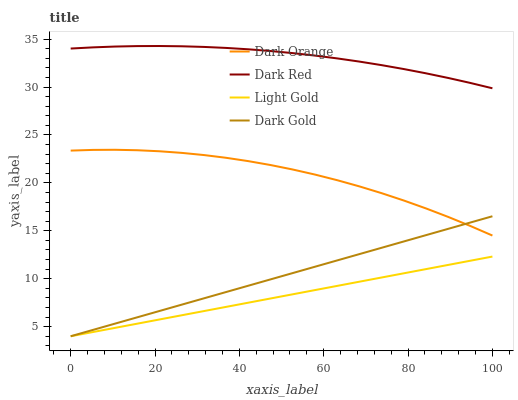Does Light Gold have the minimum area under the curve?
Answer yes or no. Yes. Does Dark Red have the maximum area under the curve?
Answer yes or no. Yes. Does Dark Gold have the minimum area under the curve?
Answer yes or no. No. Does Dark Gold have the maximum area under the curve?
Answer yes or no. No. Is Light Gold the smoothest?
Answer yes or no. Yes. Is Dark Orange the roughest?
Answer yes or no. Yes. Is Dark Gold the smoothest?
Answer yes or no. No. Is Dark Gold the roughest?
Answer yes or no. No. Does Dark Gold have the lowest value?
Answer yes or no. Yes. Does Dark Red have the lowest value?
Answer yes or no. No. Does Dark Red have the highest value?
Answer yes or no. Yes. Does Dark Gold have the highest value?
Answer yes or no. No. Is Dark Gold less than Dark Red?
Answer yes or no. Yes. Is Dark Orange greater than Light Gold?
Answer yes or no. Yes. Does Dark Orange intersect Dark Gold?
Answer yes or no. Yes. Is Dark Orange less than Dark Gold?
Answer yes or no. No. Is Dark Orange greater than Dark Gold?
Answer yes or no. No. Does Dark Gold intersect Dark Red?
Answer yes or no. No. 